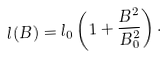<formula> <loc_0><loc_0><loc_500><loc_500>l ( B ) = l _ { 0 } \left ( 1 + \frac { B ^ { 2 } } { B ^ { 2 } _ { 0 } } \right ) .</formula> 